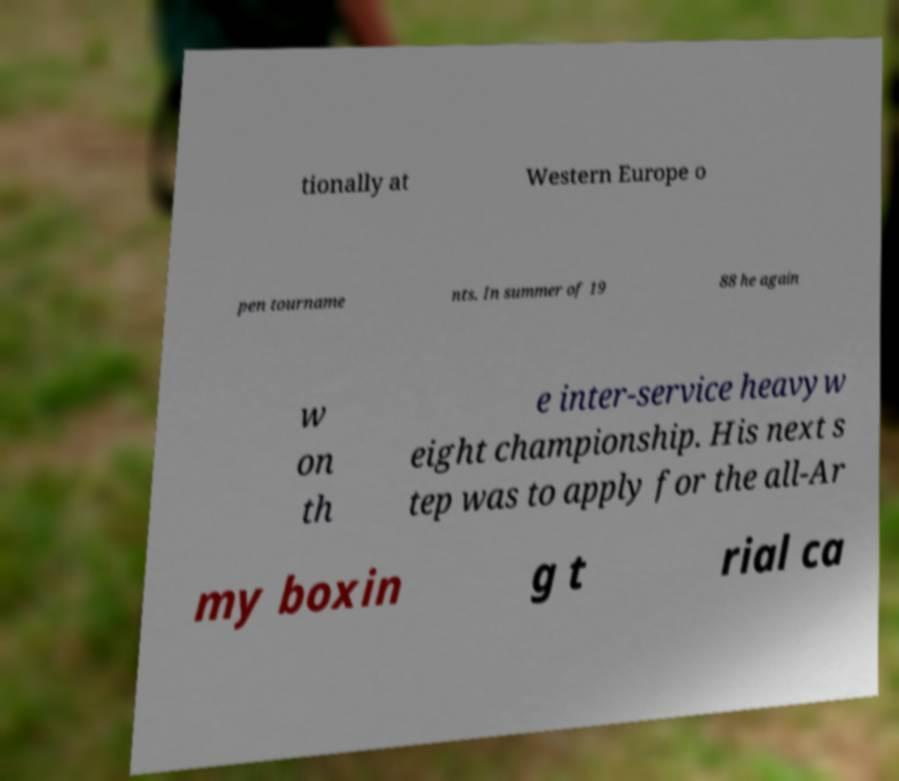Can you accurately transcribe the text from the provided image for me? tionally at Western Europe o pen tourname nts. In summer of 19 88 he again w on th e inter-service heavyw eight championship. His next s tep was to apply for the all-Ar my boxin g t rial ca 